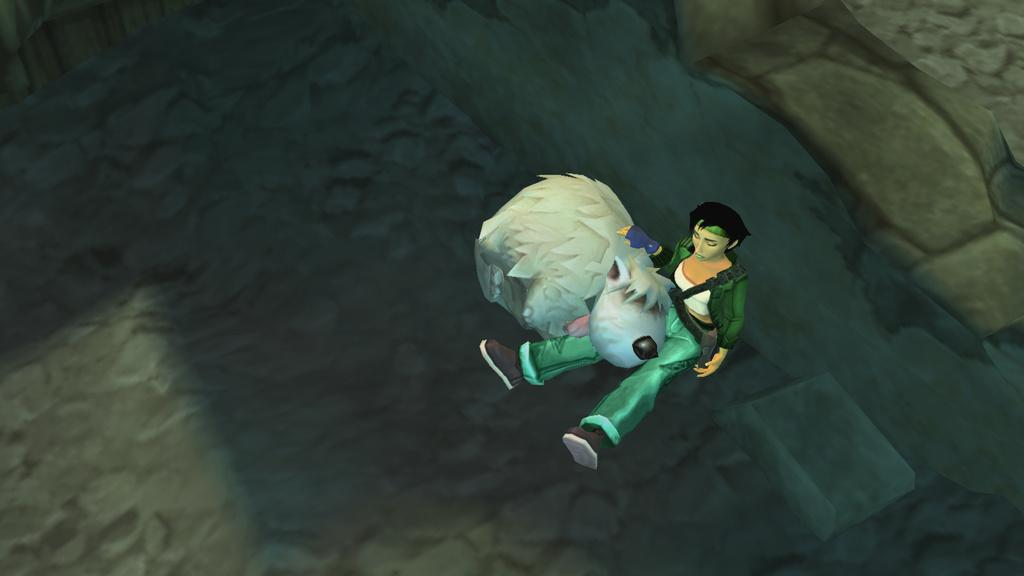Who or what is located in the center of the image? There is a woman and a dog in the center of the image. What can be seen on the right side of the image? There is a well on the right side of the image. What is on the left side of the image? There is a floor on the left side of the image. What type of insurance policy is being discussed by the woman and the dog in the image? There is no indication in the image that the woman and the dog are discussing any insurance policies. 